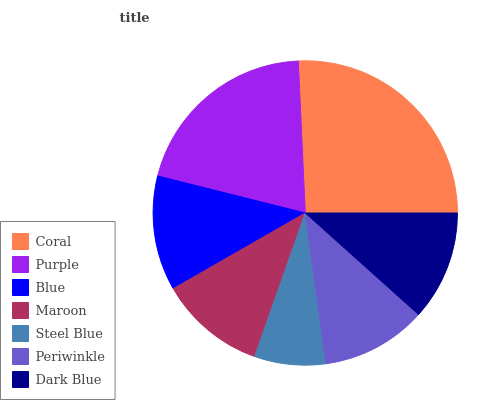Is Steel Blue the minimum?
Answer yes or no. Yes. Is Coral the maximum?
Answer yes or no. Yes. Is Purple the minimum?
Answer yes or no. No. Is Purple the maximum?
Answer yes or no. No. Is Coral greater than Purple?
Answer yes or no. Yes. Is Purple less than Coral?
Answer yes or no. Yes. Is Purple greater than Coral?
Answer yes or no. No. Is Coral less than Purple?
Answer yes or no. No. Is Dark Blue the high median?
Answer yes or no. Yes. Is Dark Blue the low median?
Answer yes or no. Yes. Is Coral the high median?
Answer yes or no. No. Is Periwinkle the low median?
Answer yes or no. No. 